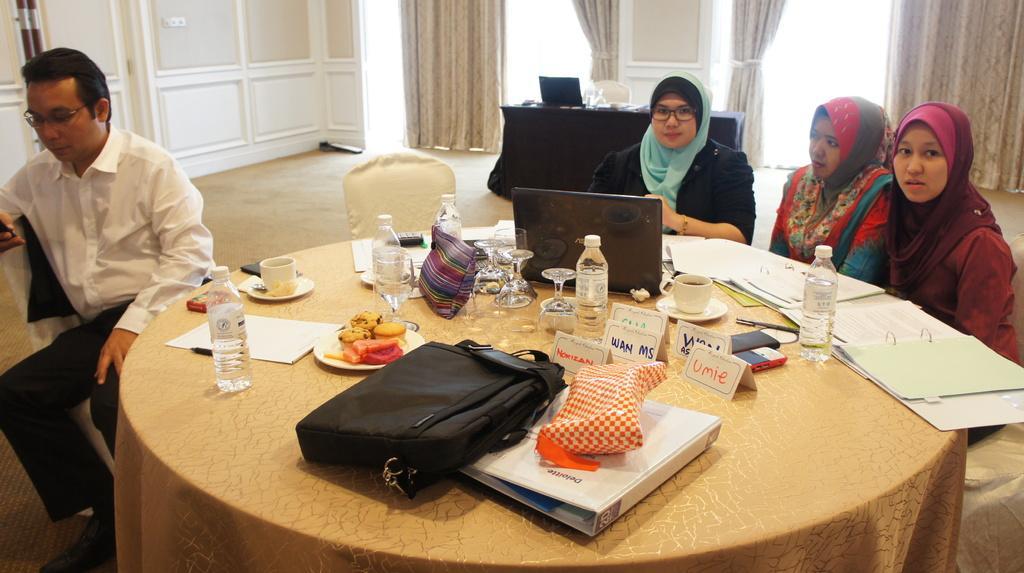Describe this image in one or two sentences. In this picture we can see three woman and one man sitting on chairs and in front o them there is table and on table we can see bag, file, name board, bottle, cup, saucer, glass, plate with food in it, papers, laptop and in background we can see windows with curtains, chair, wall. 